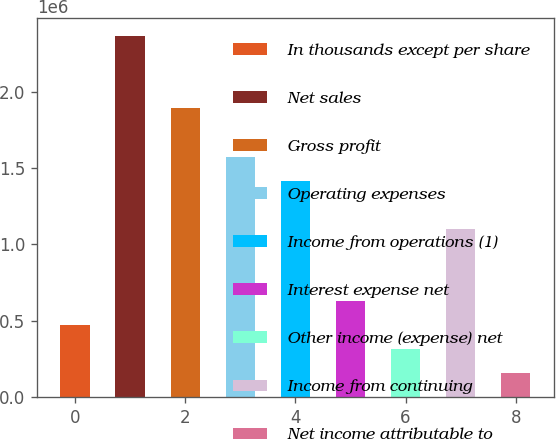Convert chart. <chart><loc_0><loc_0><loc_500><loc_500><bar_chart><fcel>In thousands except per share<fcel>Net sales<fcel>Gross profit<fcel>Operating expenses<fcel>Income from operations (1)<fcel>Interest expense net<fcel>Other income (expense) net<fcel>Income from continuing<fcel>Net income attributable to<nl><fcel>472425<fcel>2.36212e+06<fcel>1.8897e+06<fcel>1.57475e+06<fcel>1.41727e+06<fcel>629900<fcel>314950<fcel>1.10232e+06<fcel>157475<nl></chart> 